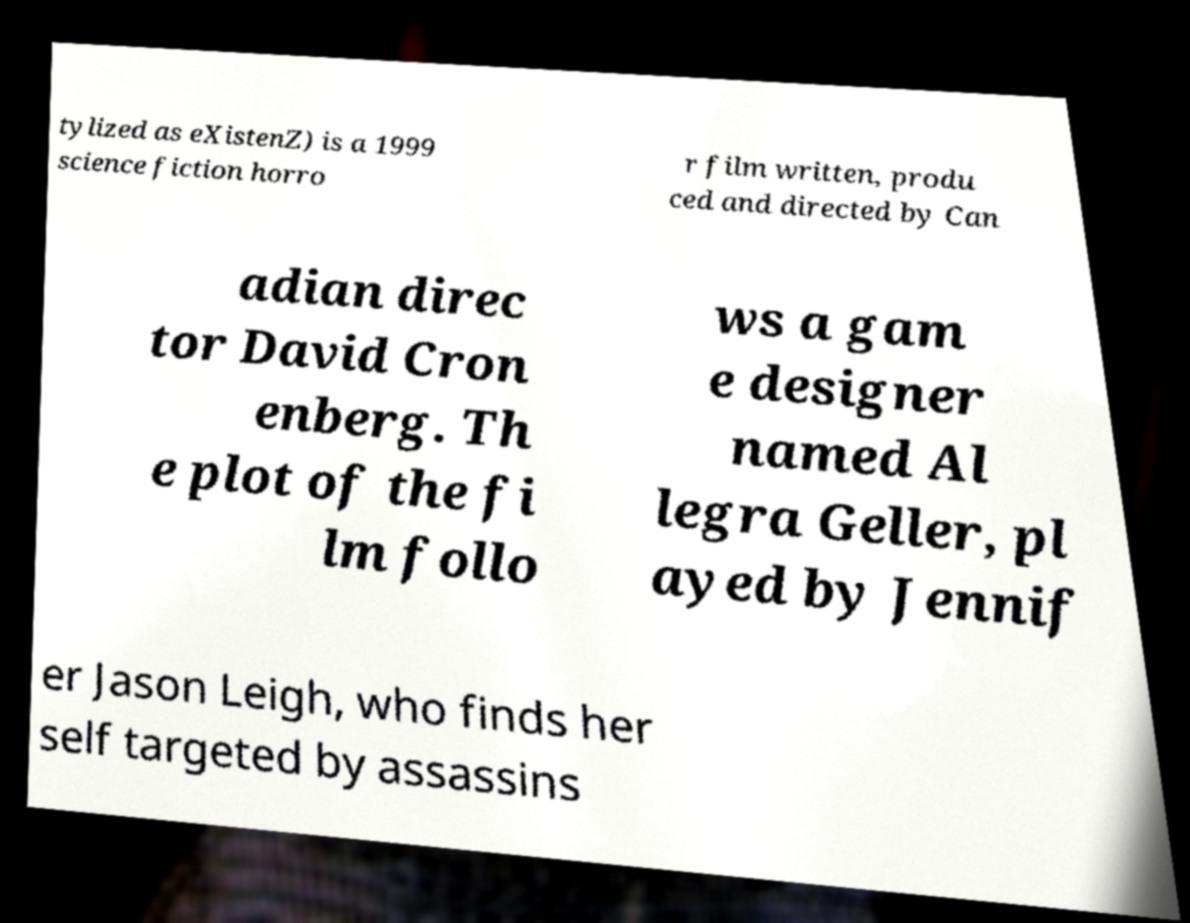Can you read and provide the text displayed in the image?This photo seems to have some interesting text. Can you extract and type it out for me? tylized as eXistenZ) is a 1999 science fiction horro r film written, produ ced and directed by Can adian direc tor David Cron enberg. Th e plot of the fi lm follo ws a gam e designer named Al legra Geller, pl ayed by Jennif er Jason Leigh, who finds her self targeted by assassins 